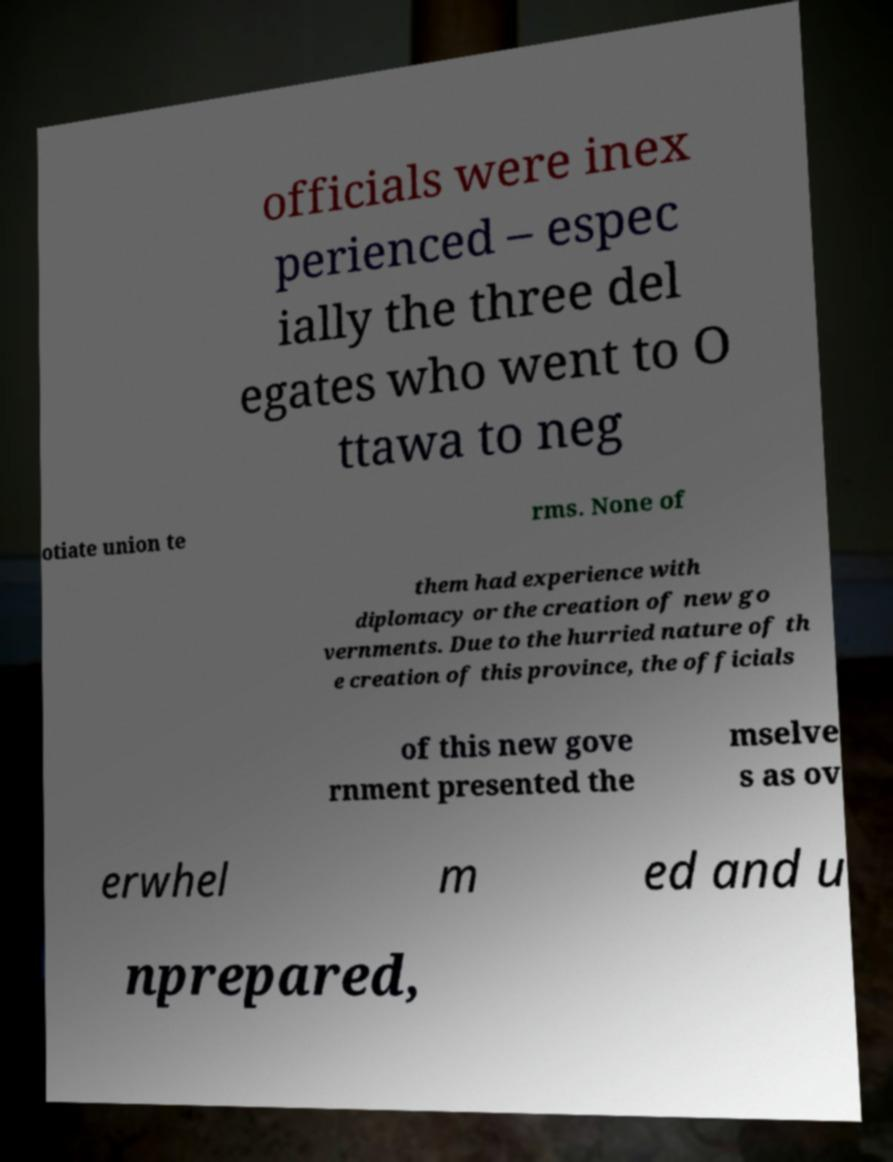Can you accurately transcribe the text from the provided image for me? officials were inex perienced – espec ially the three del egates who went to O ttawa to neg otiate union te rms. None of them had experience with diplomacy or the creation of new go vernments. Due to the hurried nature of th e creation of this province, the officials of this new gove rnment presented the mselve s as ov erwhel m ed and u nprepared, 